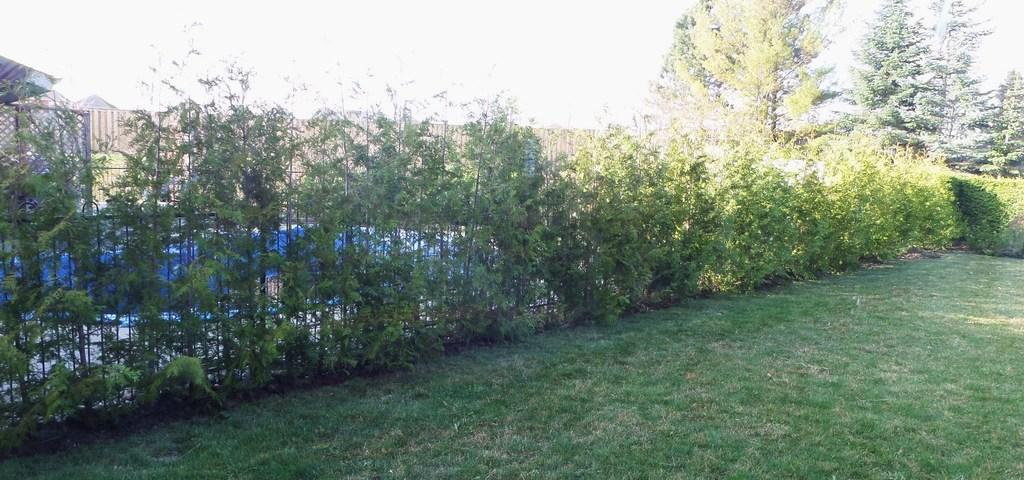What can be seen in the sky in the image? The sky is visible in the image. What type of vegetation is present in the image? There are plants and trees in the image. What is the surface on which the plants and trees are growing? The ground is visible in the image. What structures can be seen in the image? There is a fence and a shed in the image. What type of vegetable is growing on the fence in the image? There are no vegetables present in the image, and the fence is not associated with any vegetable growth. 